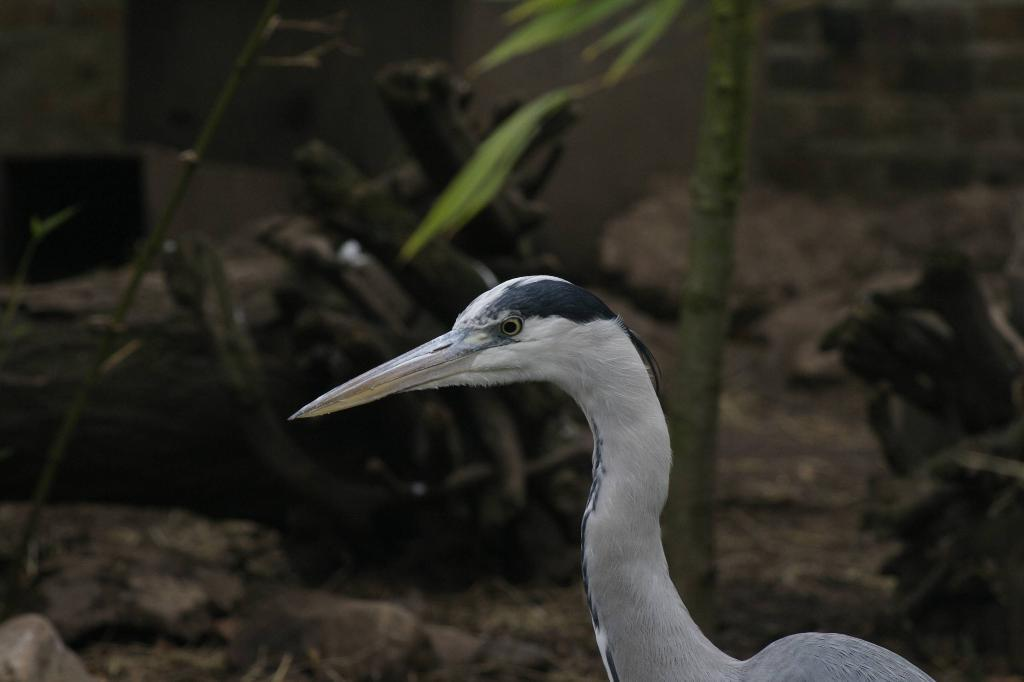What type of animal is in the image? There is a bird in the image. What colors can be seen on the bird? The bird is white and black in color. What can be seen in the background of the image? There are plants and rocks in the background of the image. Can you see any rings on the bird's legs in the image? There are no rings visible on the bird's legs in the image. What type of alley is visible in the background of the image? There is no alley present in the image; it features a bird, plants, and rocks in the background. 